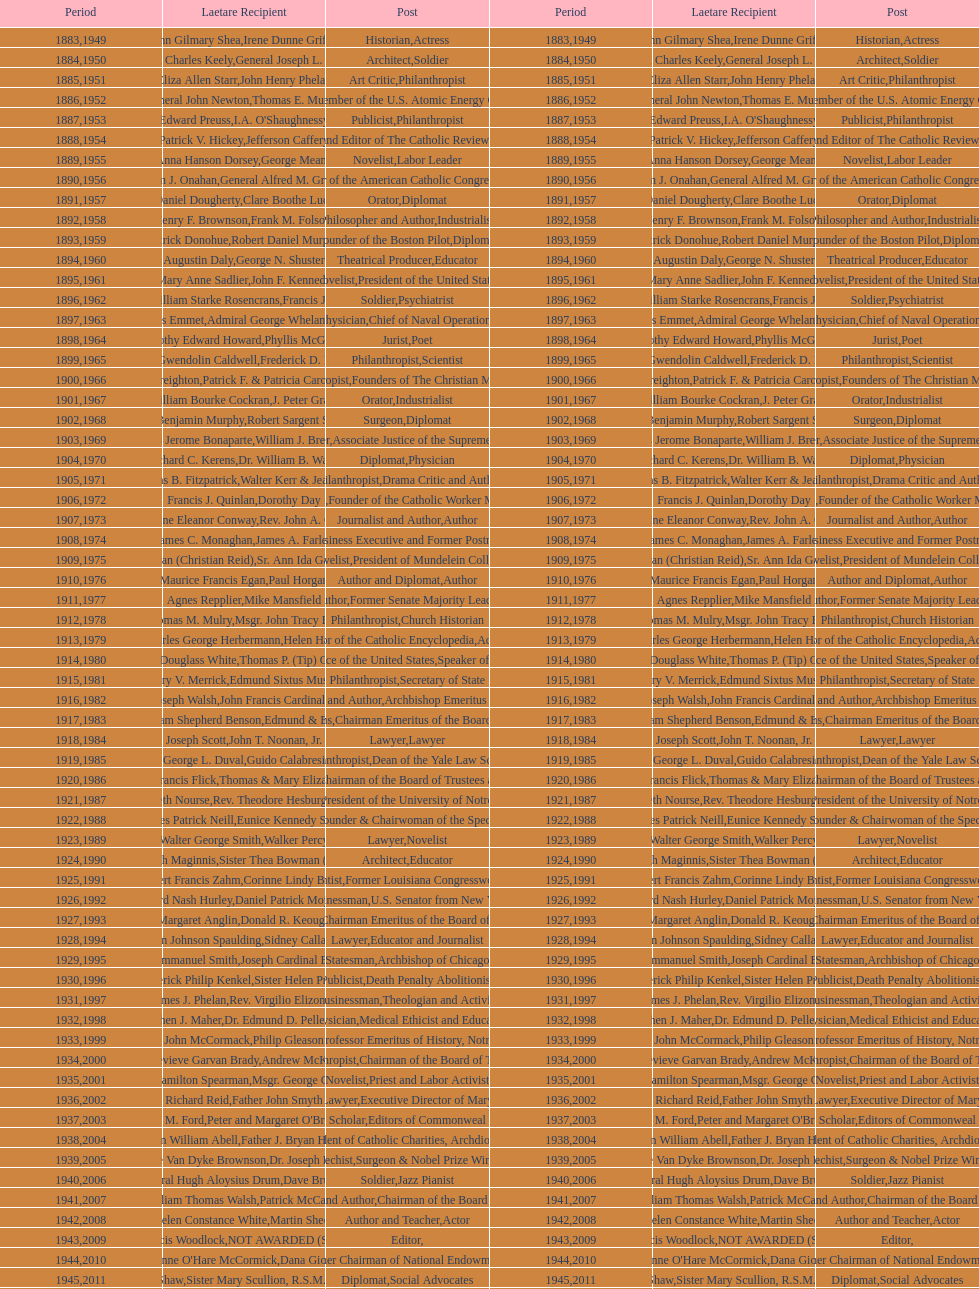Who was the previous winner before john henry phelan in 1951? General Joseph L. Collins. 